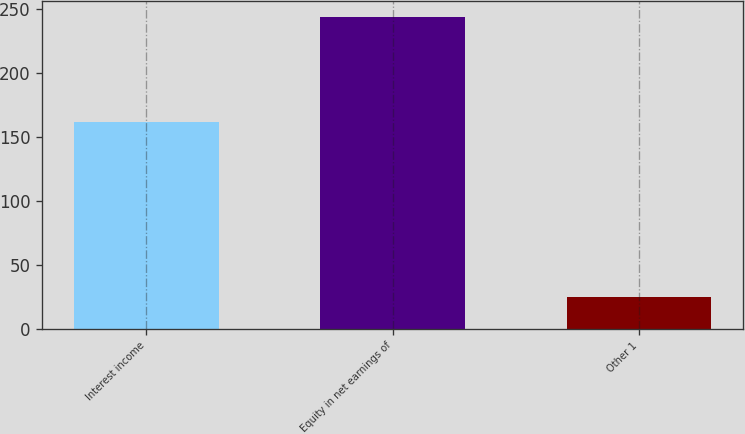<chart> <loc_0><loc_0><loc_500><loc_500><bar_chart><fcel>Interest income<fcel>Equity in net earnings of<fcel>Other 1<nl><fcel>162<fcel>244<fcel>25<nl></chart> 